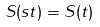Convert formula to latex. <formula><loc_0><loc_0><loc_500><loc_500>S ( s t ) = S ( t )</formula> 